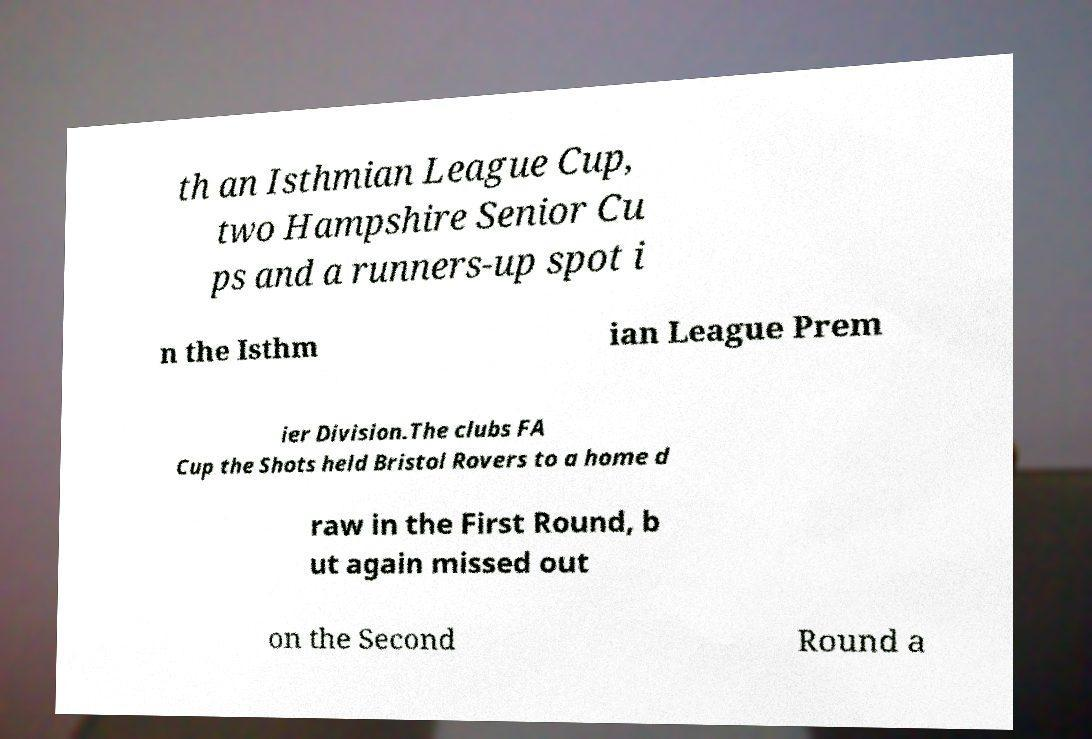Please identify and transcribe the text found in this image. th an Isthmian League Cup, two Hampshire Senior Cu ps and a runners-up spot i n the Isthm ian League Prem ier Division.The clubs FA Cup the Shots held Bristol Rovers to a home d raw in the First Round, b ut again missed out on the Second Round a 